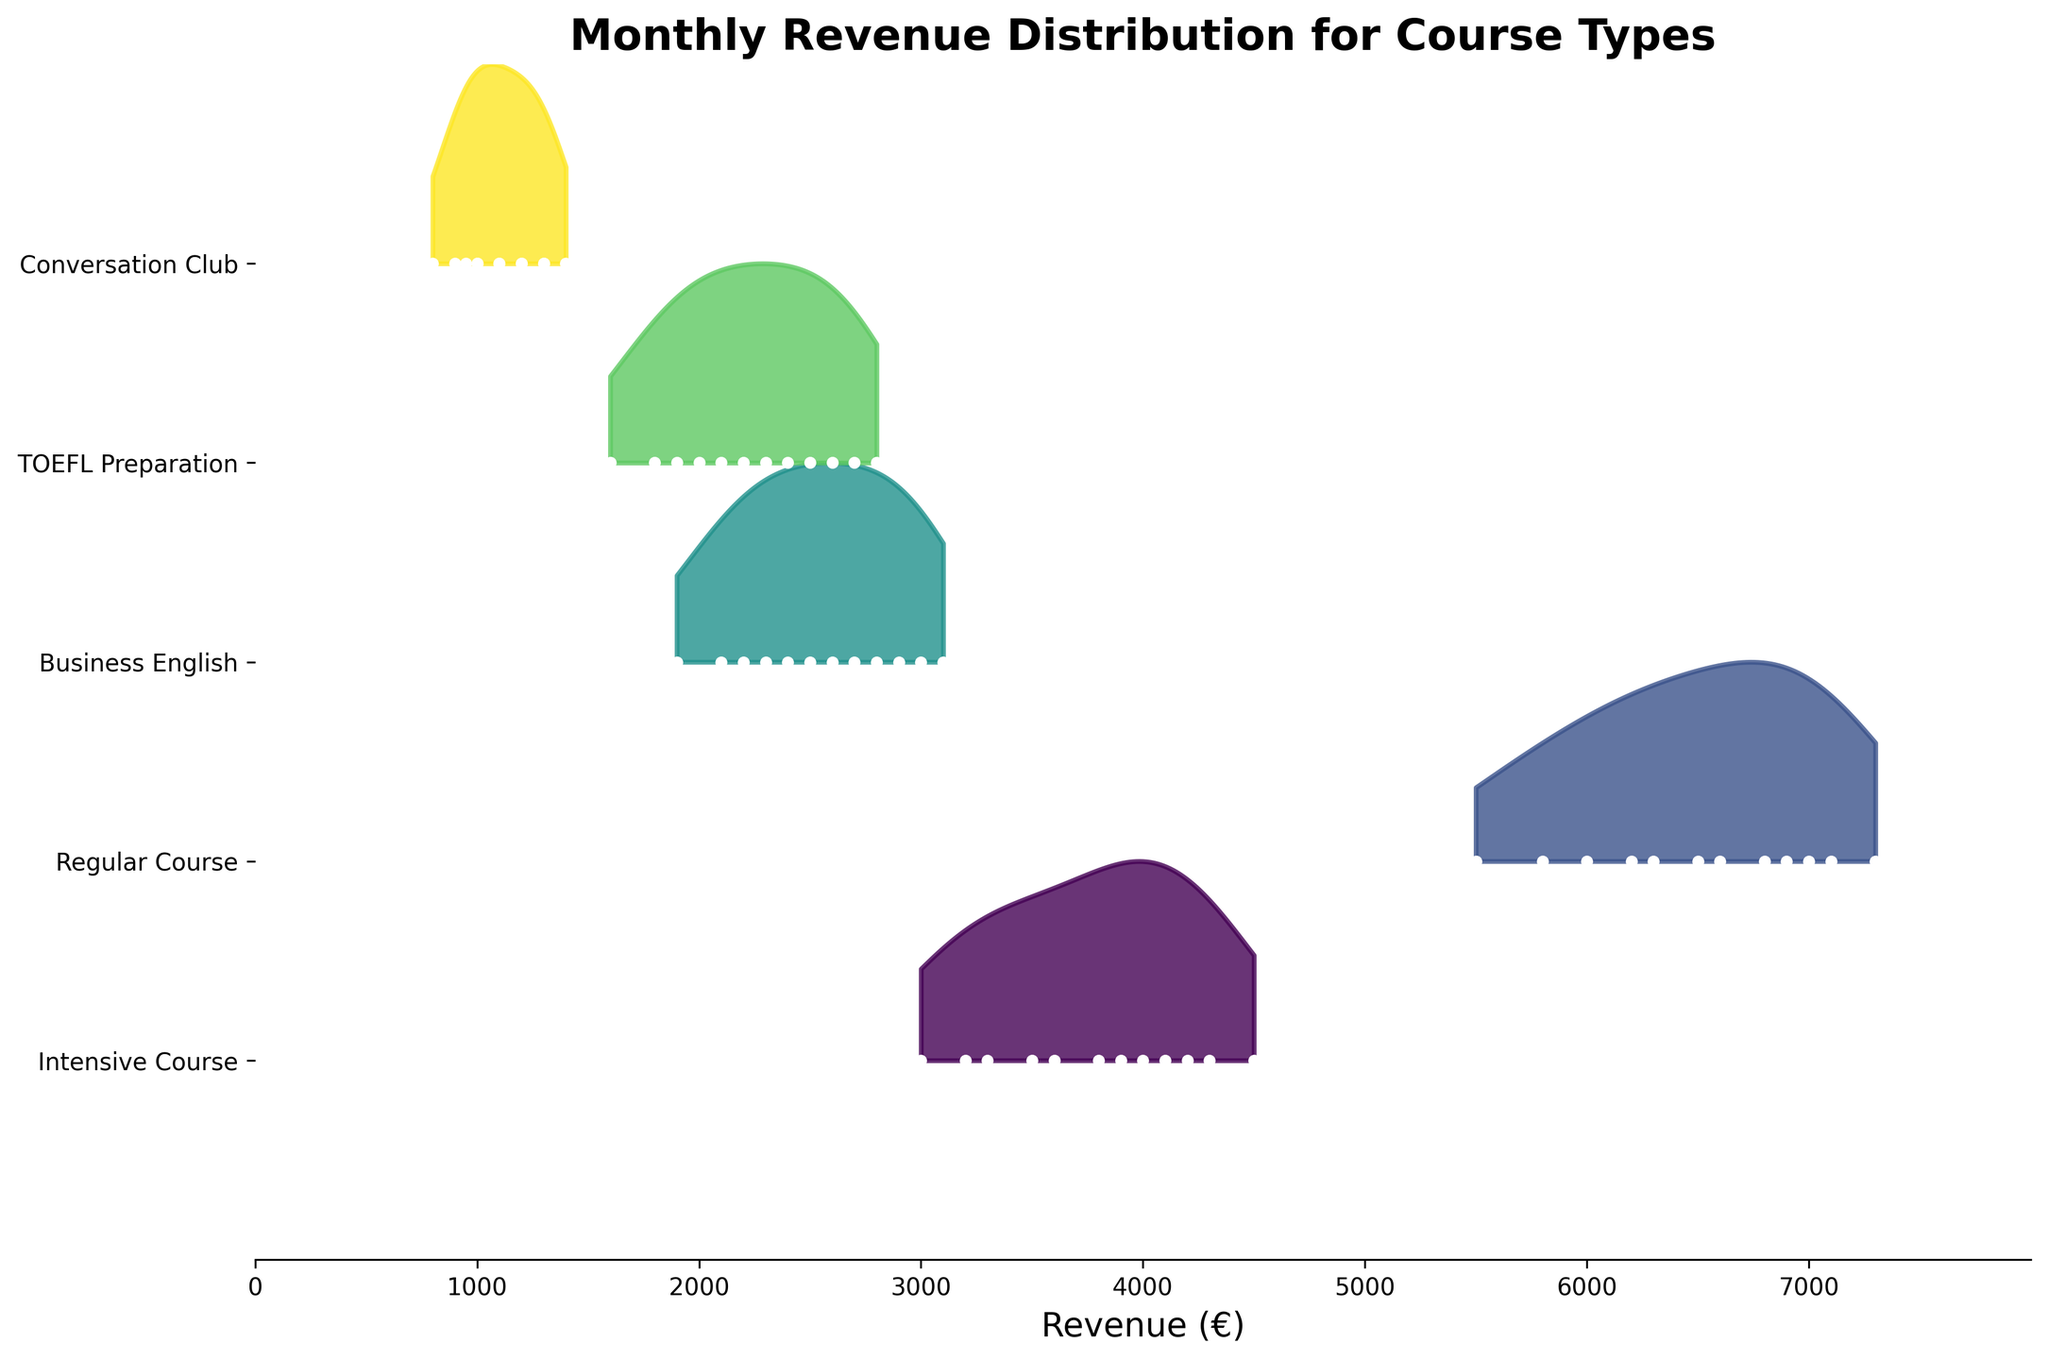What is the title of the plot? The title is located at the top of the plot. It summarizes the subject of the figure.
Answer: Monthly Revenue Distribution for Course Types What do the y-axis labels represent? The labels on the y-axis represent the different course types available at the English language academy.
Answer: Intensive Course, Regular Course, Business English, TOEFL Preparation, Conversation Club Which course type generally shows the highest monthly revenue? By looking at the distribution curves and their position on the x-axis, the course with the most consistently high revenue can be identified.
Answer: Regular Course During which month do all courses likely have the lowest revenue? By observing the filled curves and the month with the lowest points for each course, the lowest revenue month can be determined.
Answer: August Which course type shows the most variation in revenue throughout the year? By looking at the spread and range of the distribution curves for each course type, the one with the widest range can be identified.
Answer: Intensive Course How does the revenue of the Conversation Club in January compare to other months? The position of the data point for January on the y-axis for Conversation Club can be checked against other months to see if January is higher, lower, or similar.
Answer: Higher In which month does the Business English course reach its peak revenue? By identifying the highest point on the distribution curve for the Business English course, the peak month can be found.
Answer: March What is the revenue trend for the TOEFL Preparation course from November to March? Looking at the positions of the TOEFL Preparation course data points from November to March reveals an increasing or decreasing trend over these months.
Answer: Increasing Which month shows a significant drop in revenue for the Regular Course? By looking at the distribution for the Regular Course, the month with the most noticeable decrease can be identified.
Answer: July What can you infer about the overall revenue trends across all course types in the summer months? By examining the positions and heights of the distribution curves for all courses in June, July, and August, we can infer if there is a general trend.
Answer: Decline 